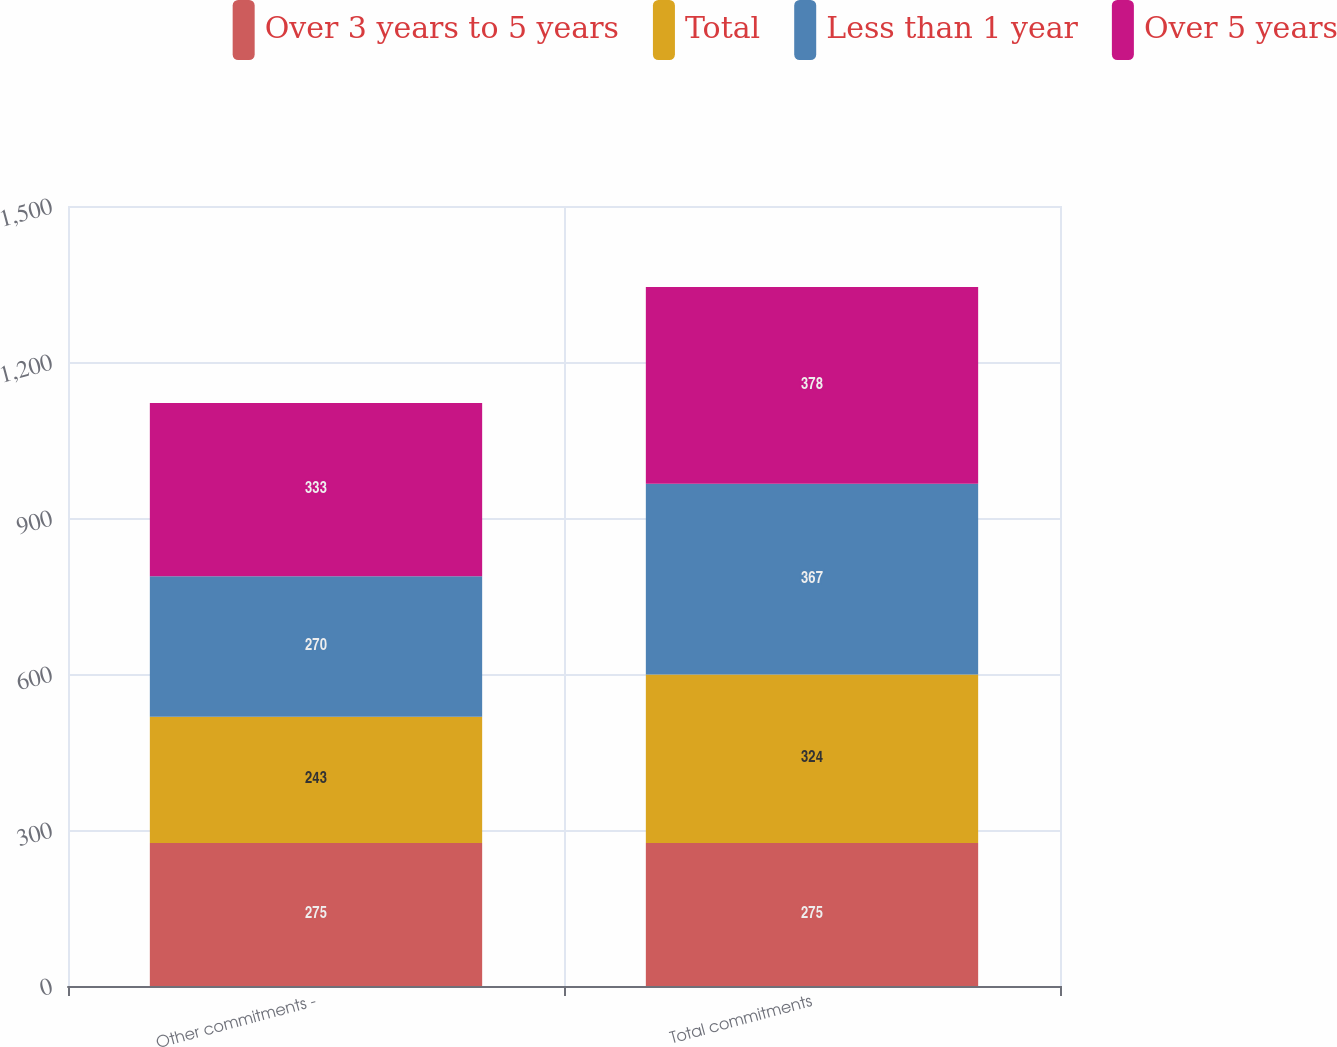Convert chart to OTSL. <chart><loc_0><loc_0><loc_500><loc_500><stacked_bar_chart><ecel><fcel>Other commitments -<fcel>Total commitments<nl><fcel>Over 3 years to 5 years<fcel>275<fcel>275<nl><fcel>Total<fcel>243<fcel>324<nl><fcel>Less than 1 year<fcel>270<fcel>367<nl><fcel>Over 5 years<fcel>333<fcel>378<nl></chart> 